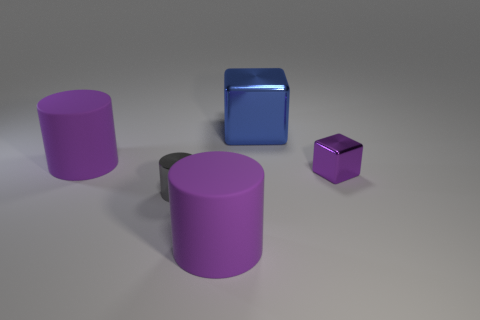How does the lighting in the image affect the appearance of the objects? The lighting in the image is subtle and diffused, providing a gentle illumination that casts soft shadows beneath the objects. This contributes to a serene atmosphere and accentuates the objects' colors and textures, while also highlighting the reflective properties of the metallic surfaces. 